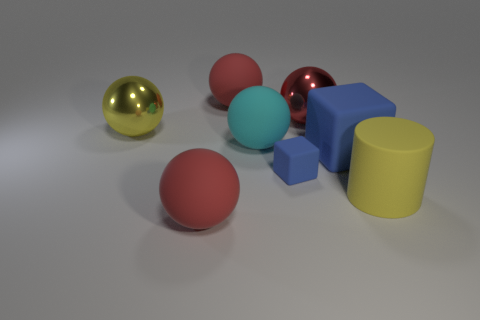What is the shape of the big yellow object behind the big cyan thing?
Your answer should be very brief. Sphere. Do the red shiny sphere and the red thing that is in front of the large rubber cylinder have the same size?
Keep it short and to the point. Yes. Are there any small purple balls that have the same material as the big cyan sphere?
Offer a terse response. No. What number of balls are large red rubber things or small blue matte things?
Your answer should be compact. 2. There is a small blue rubber object that is in front of the cyan rubber sphere; are there any large things that are in front of it?
Provide a short and direct response. Yes. Are there fewer large red rubber balls than small rubber blocks?
Offer a terse response. No. What number of other objects are the same shape as the cyan matte thing?
Your answer should be very brief. 4. How many cyan things are either rubber cubes or large cylinders?
Make the answer very short. 0. What size is the yellow object that is on the left side of the blue cube left of the red shiny sphere?
Ensure brevity in your answer.  Large. There is a large blue thing that is the same shape as the small blue rubber object; what is its material?
Your response must be concise. Rubber. 